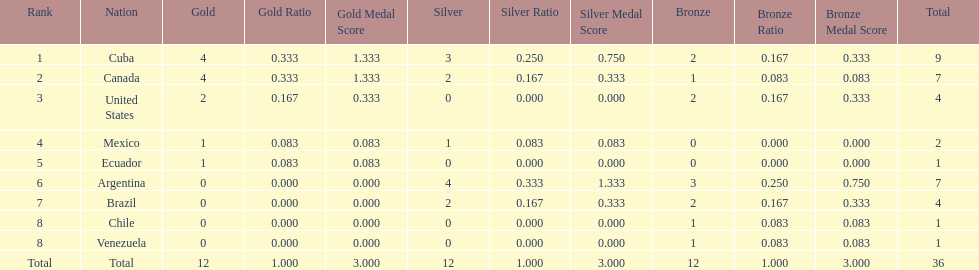Give me the full table as a dictionary. {'header': ['Rank', 'Nation', 'Gold', 'Gold Ratio', 'Gold Medal Score', 'Silver', 'Silver Ratio', 'Silver Medal Score', 'Bronze', 'Bronze Ratio', 'Bronze Medal Score', 'Total'], 'rows': [['1', 'Cuba', '4', '0.333', '1.333', '3', '0.250', '0.750', '2', '0.167', '0.333', '9'], ['2', 'Canada', '4', '0.333', '1.333', '2', '0.167', '0.333', '1', '0.083', '0.083', '7'], ['3', 'United States', '2', '0.167', '0.333', '0', '0.000', '0.000', '2', '0.167', '0.333', '4'], ['4', 'Mexico', '1', '0.083', '0.083', '1', '0.083', '0.083', '0', '0.000', '0.000', '2'], ['5', 'Ecuador', '1', '0.083', '0.083', '0', '0.000', '0.000', '0', '0.000', '0.000', '1'], ['6', 'Argentina', '0', '0.000', '0.000', '4', '0.333', '1.333', '3', '0.250', '0.750', '7'], ['7', 'Brazil', '0', '0.000', '0.000', '2', '0.167', '0.333', '2', '0.167', '0.333', '4'], ['8', 'Chile', '0', '0.000', '0.000', '0', '0.000', '0.000', '1', '0.083', '0.083', '1'], ['8', 'Venezuela', '0', '0.000', '0.000', '0', '0.000', '0.000', '1', '0.083', '0.083', '1'], ['Total', 'Total', '12', '1.000', '3.000', '12', '1.000', '3.000', '12', '1.000', '3.000', '36']]} What is the total number of nations that did not win gold? 4. 